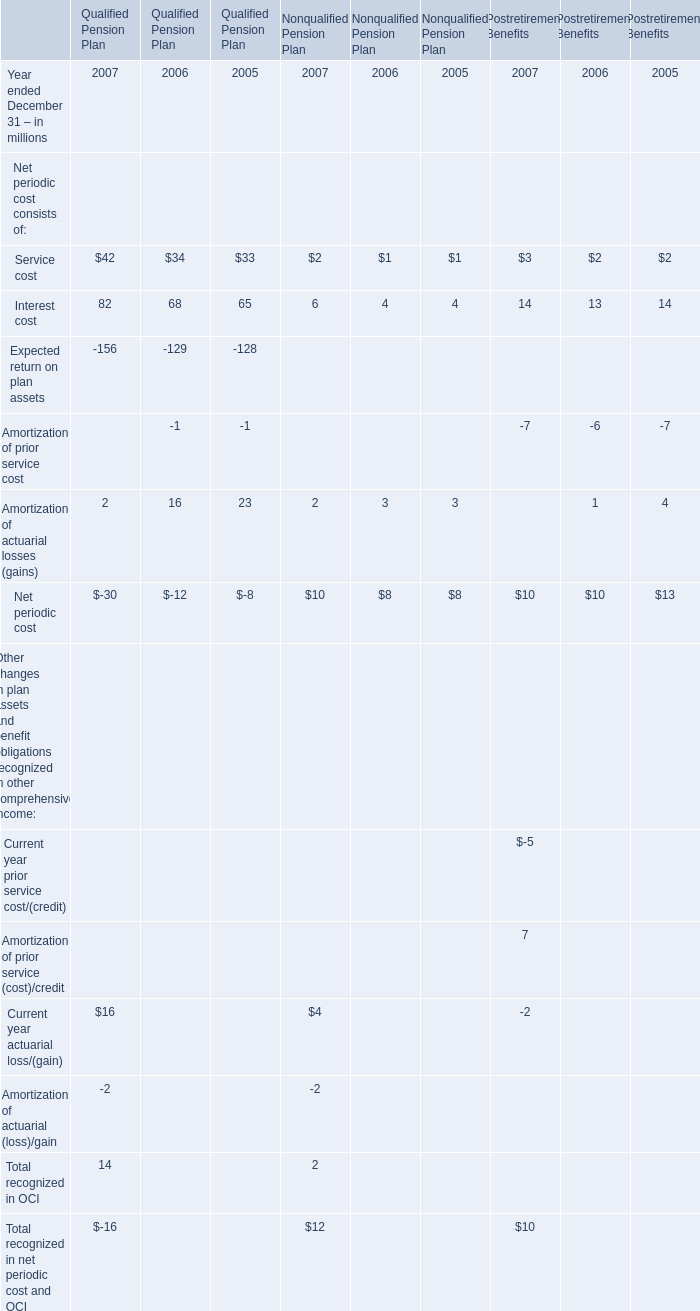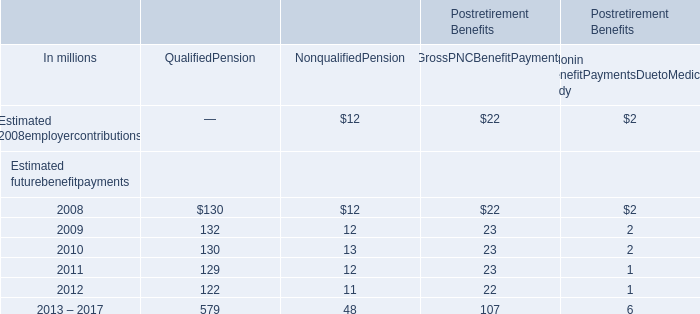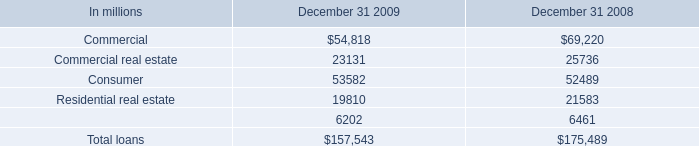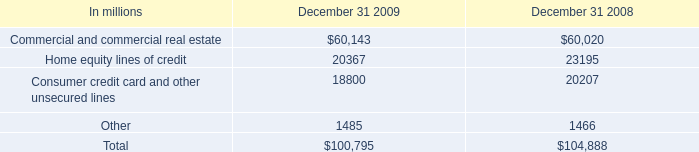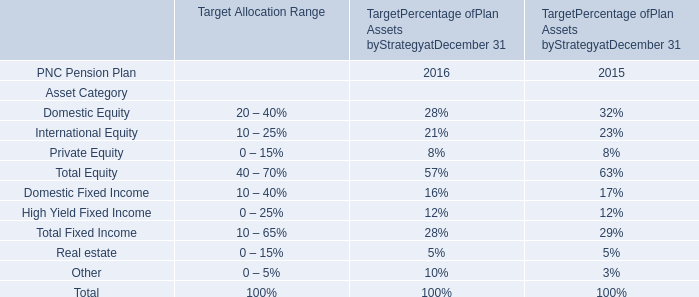What is the sum of Estimated futurebenefitpayments in the range of 0 and 30 in 2009? (in million) 
Computations: ((12 + 23) + 2)
Answer: 37.0. 